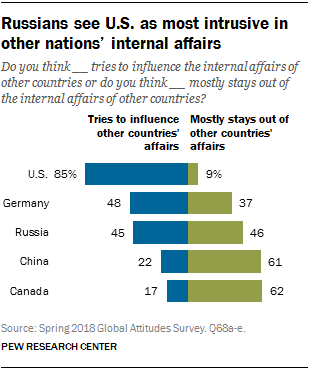Specify some key components in this picture. The color of the longest section of the U.S. bar is blue. The average value of the blue bars in the graph, representing Germany, Russia, China, and Canada, is approximately 33. 